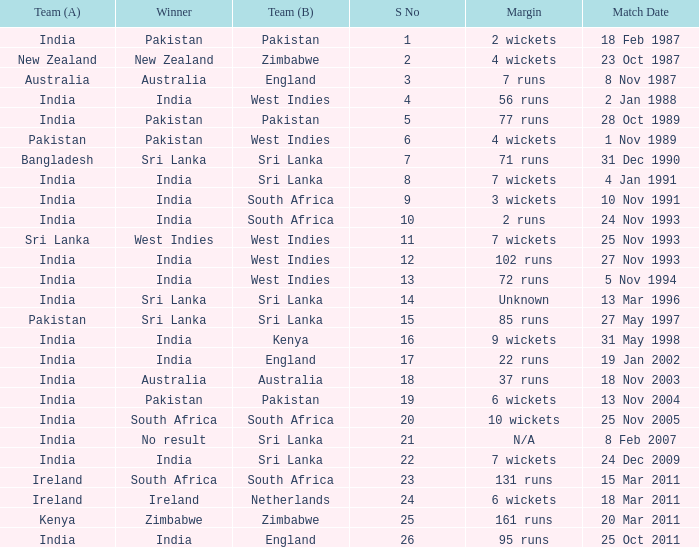Who won the match when the margin was 131 runs? South Africa. 